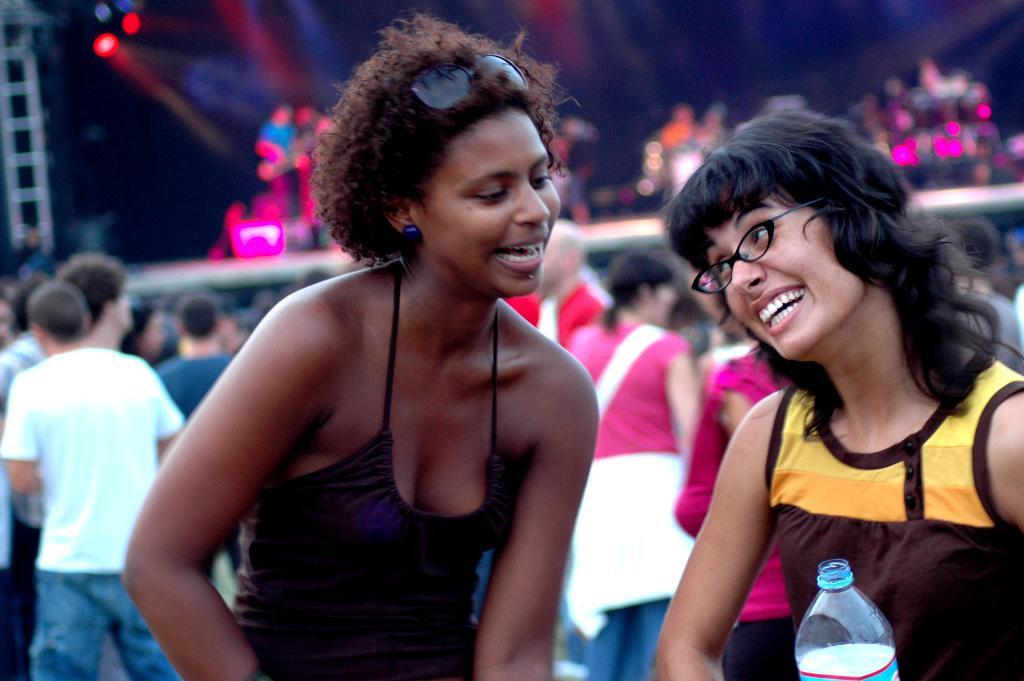What can be observed about the people in the image? There are people standing in the image. Can you describe the appearance of the woman on the right side? The woman on the right side is wearing spectacles. What is the woman on the right side holding in her hand? The woman on the right side is holding a bottle in her hand. How would you describe the background of the image? The background of the image is blurry. Can you hear the robin sneezing in the image? There is no robin or sneezing present in the image. 